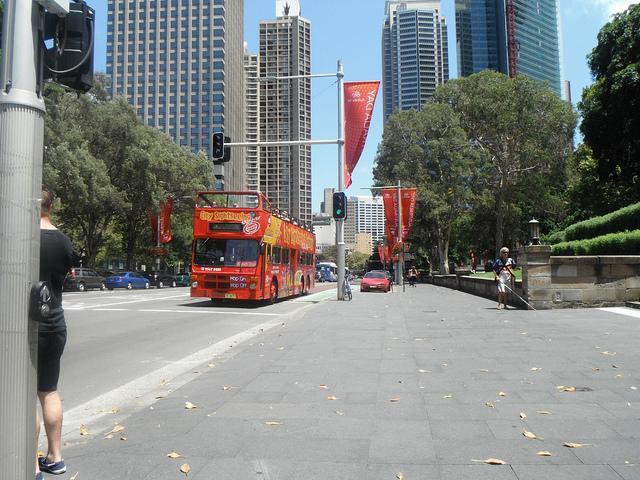What country do you think this is in?
Write a very short answer. Usa. Is the traffic light green?
Short answer required. Yes. Is that a tour bus?
Keep it brief. Yes. 